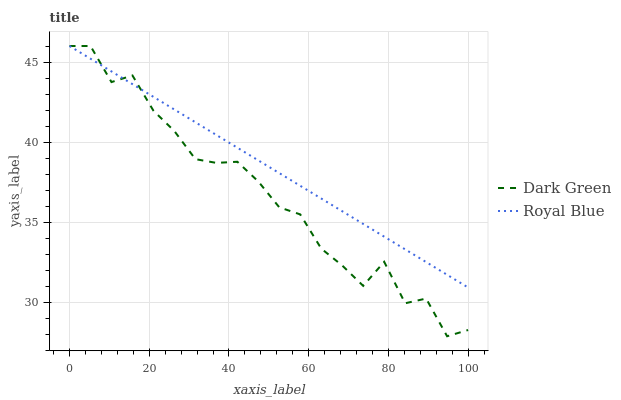Does Dark Green have the minimum area under the curve?
Answer yes or no. Yes. Does Royal Blue have the maximum area under the curve?
Answer yes or no. Yes. Does Dark Green have the maximum area under the curve?
Answer yes or no. No. Is Royal Blue the smoothest?
Answer yes or no. Yes. Is Dark Green the roughest?
Answer yes or no. Yes. Is Dark Green the smoothest?
Answer yes or no. No. Does Dark Green have the highest value?
Answer yes or no. Yes. 